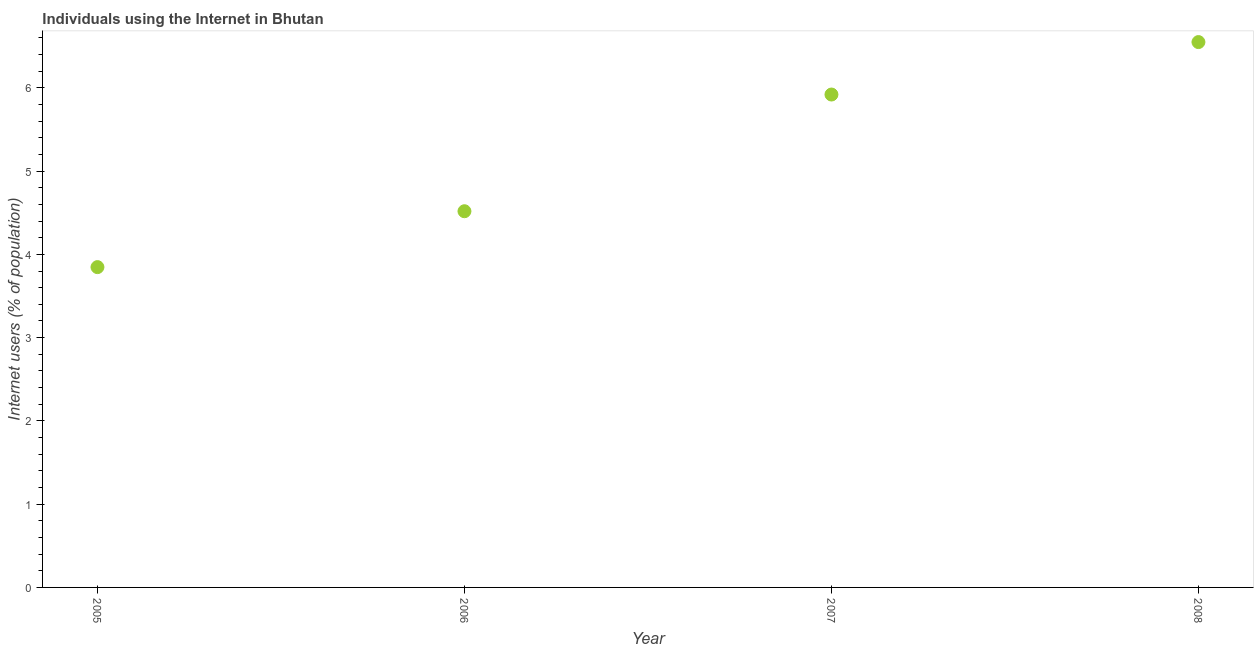What is the number of internet users in 2006?
Give a very brief answer. 4.52. Across all years, what is the maximum number of internet users?
Keep it short and to the point. 6.55. Across all years, what is the minimum number of internet users?
Your answer should be compact. 3.85. What is the sum of the number of internet users?
Your response must be concise. 20.84. What is the difference between the number of internet users in 2005 and 2006?
Make the answer very short. -0.67. What is the average number of internet users per year?
Make the answer very short. 5.21. What is the median number of internet users?
Keep it short and to the point. 5.22. In how many years, is the number of internet users greater than 5.4 %?
Provide a succinct answer. 2. What is the ratio of the number of internet users in 2005 to that in 2007?
Ensure brevity in your answer.  0.65. Is the number of internet users in 2006 less than that in 2008?
Give a very brief answer. Yes. Is the difference between the number of internet users in 2005 and 2007 greater than the difference between any two years?
Provide a succinct answer. No. What is the difference between the highest and the second highest number of internet users?
Offer a very short reply. 0.63. What is the difference between the highest and the lowest number of internet users?
Give a very brief answer. 2.7. In how many years, is the number of internet users greater than the average number of internet users taken over all years?
Offer a very short reply. 2. Does the number of internet users monotonically increase over the years?
Offer a terse response. Yes. How many dotlines are there?
Ensure brevity in your answer.  1. Does the graph contain any zero values?
Your answer should be compact. No. What is the title of the graph?
Your response must be concise. Individuals using the Internet in Bhutan. What is the label or title of the X-axis?
Make the answer very short. Year. What is the label or title of the Y-axis?
Ensure brevity in your answer.  Internet users (% of population). What is the Internet users (% of population) in 2005?
Provide a short and direct response. 3.85. What is the Internet users (% of population) in 2006?
Keep it short and to the point. 4.52. What is the Internet users (% of population) in 2007?
Make the answer very short. 5.92. What is the Internet users (% of population) in 2008?
Make the answer very short. 6.55. What is the difference between the Internet users (% of population) in 2005 and 2006?
Your answer should be very brief. -0.67. What is the difference between the Internet users (% of population) in 2005 and 2007?
Give a very brief answer. -2.07. What is the difference between the Internet users (% of population) in 2005 and 2008?
Ensure brevity in your answer.  -2.7. What is the difference between the Internet users (% of population) in 2006 and 2007?
Provide a short and direct response. -1.4. What is the difference between the Internet users (% of population) in 2006 and 2008?
Your answer should be compact. -2.03. What is the difference between the Internet users (% of population) in 2007 and 2008?
Your answer should be compact. -0.63. What is the ratio of the Internet users (% of population) in 2005 to that in 2006?
Offer a very short reply. 0.85. What is the ratio of the Internet users (% of population) in 2005 to that in 2007?
Offer a very short reply. 0.65. What is the ratio of the Internet users (% of population) in 2005 to that in 2008?
Your answer should be compact. 0.59. What is the ratio of the Internet users (% of population) in 2006 to that in 2007?
Ensure brevity in your answer.  0.76. What is the ratio of the Internet users (% of population) in 2006 to that in 2008?
Your answer should be compact. 0.69. What is the ratio of the Internet users (% of population) in 2007 to that in 2008?
Your answer should be very brief. 0.9. 